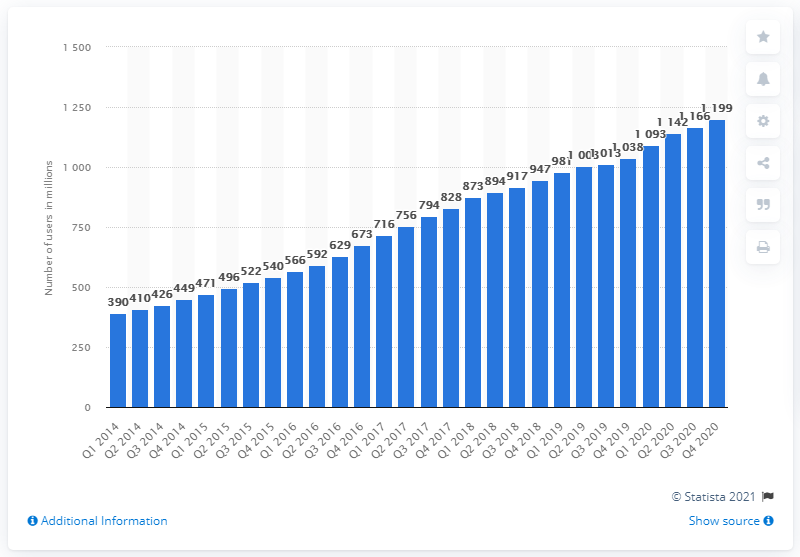Point out several critical features in this image. In the fourth quarter of 2020, there were 1,199 monthly active Facebook users in the Asia Pacific region. In the first quarter of 2014, there were approximately 390 monthly active Facebook users. 